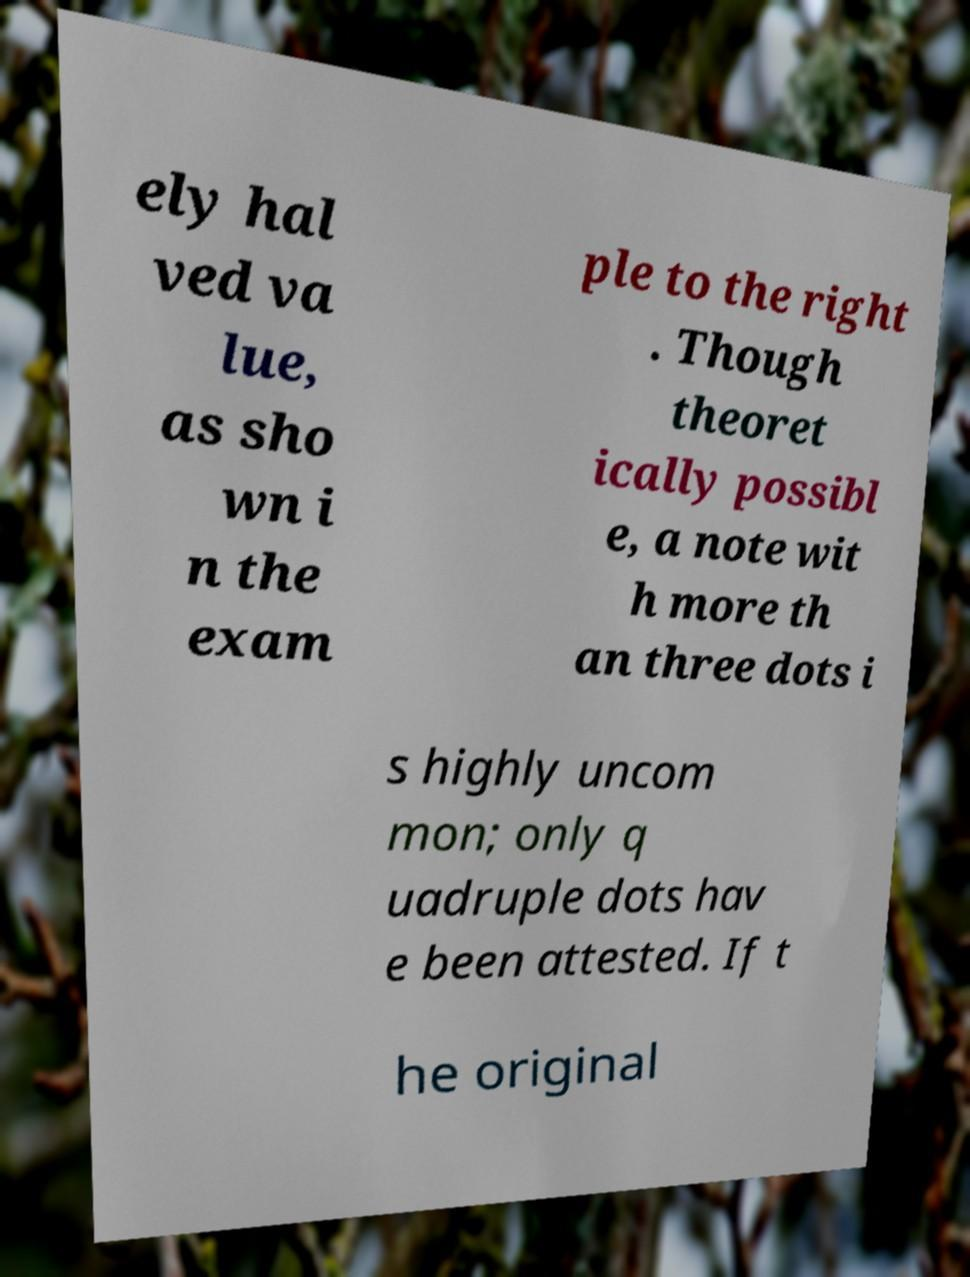Can you accurately transcribe the text from the provided image for me? ely hal ved va lue, as sho wn i n the exam ple to the right . Though theoret ically possibl e, a note wit h more th an three dots i s highly uncom mon; only q uadruple dots hav e been attested. If t he original 